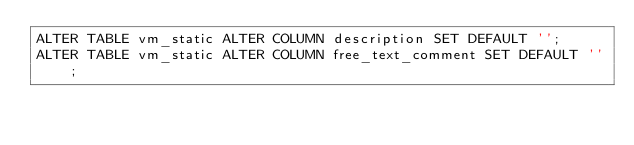<code> <loc_0><loc_0><loc_500><loc_500><_SQL_>ALTER TABLE vm_static ALTER COLUMN description SET DEFAULT '';
ALTER TABLE vm_static ALTER COLUMN free_text_comment SET DEFAULT '';

</code> 